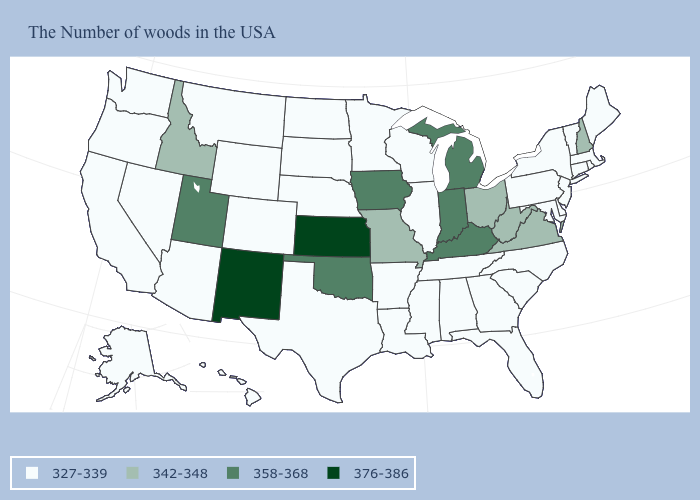What is the value of Oklahoma?
Quick response, please. 358-368. What is the value of Tennessee?
Answer briefly. 327-339. What is the value of Massachusetts?
Quick response, please. 327-339. Which states hav the highest value in the South?
Answer briefly. Kentucky, Oklahoma. Name the states that have a value in the range 358-368?
Quick response, please. Michigan, Kentucky, Indiana, Iowa, Oklahoma, Utah. Name the states that have a value in the range 358-368?
Short answer required. Michigan, Kentucky, Indiana, Iowa, Oklahoma, Utah. What is the value of Texas?
Be succinct. 327-339. Which states hav the highest value in the MidWest?
Keep it brief. Kansas. Is the legend a continuous bar?
Short answer required. No. How many symbols are there in the legend?
Quick response, please. 4. What is the lowest value in states that border Nebraska?
Answer briefly. 327-339. What is the value of Indiana?
Keep it brief. 358-368. What is the value of California?
Answer briefly. 327-339. What is the value of Delaware?
Answer briefly. 327-339. 